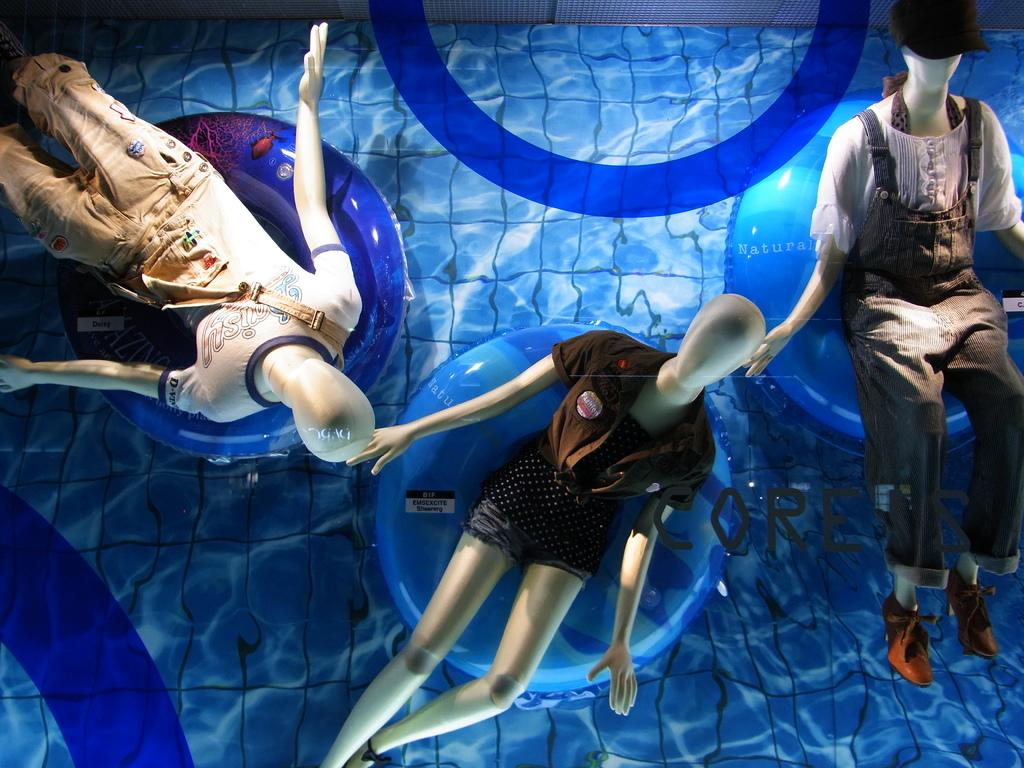How many dolls are present in the image? There are three dolls in the image. What are the dolls wearing? The dolls are wearing dresses. Where are the dolls sitting? The dolls are sitting on tubes. What is the location of the tubes in the image? The tubes are placed on the water. Can you tell me what your uncle is doing with the dolls in the image? There is no uncle present in the image, and therefore no interaction with the dolls can be observed. 